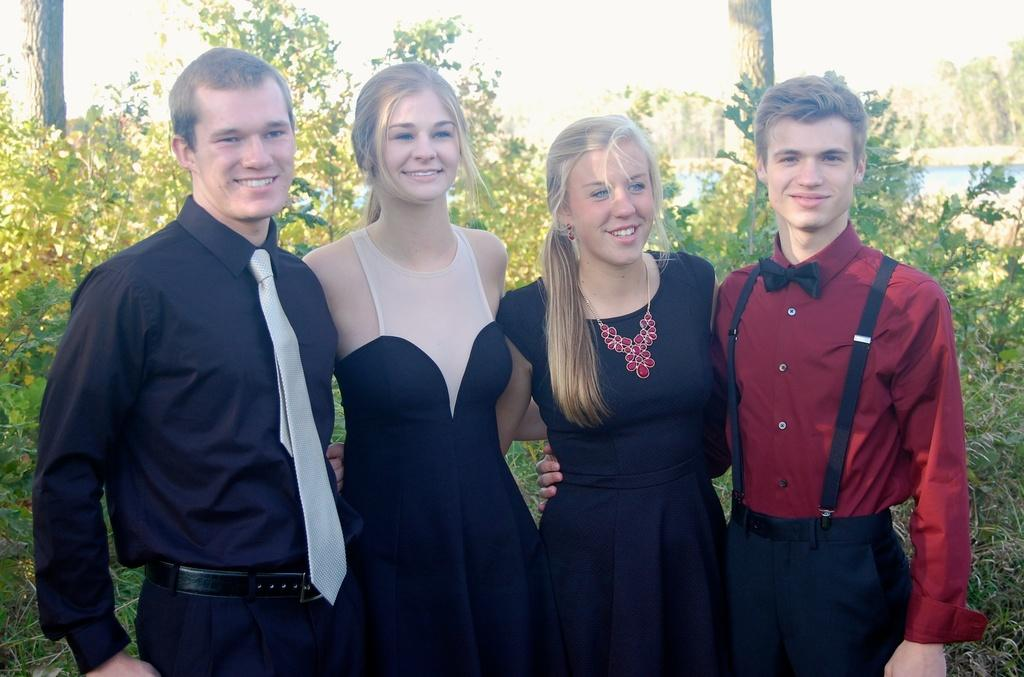How many people are present in the image? There are four people in the image, two men and two women. What is the facial expression of the people in the image? The people in the image are smiling. What can be seen in the background of the image? There are trees in the background of the image. What type of joke is the committee telling in the image? There is no committee or joke present in the image; it features four people smiling. Can you tell me how many turkeys are visible in the image? There are no turkeys present in the image. 